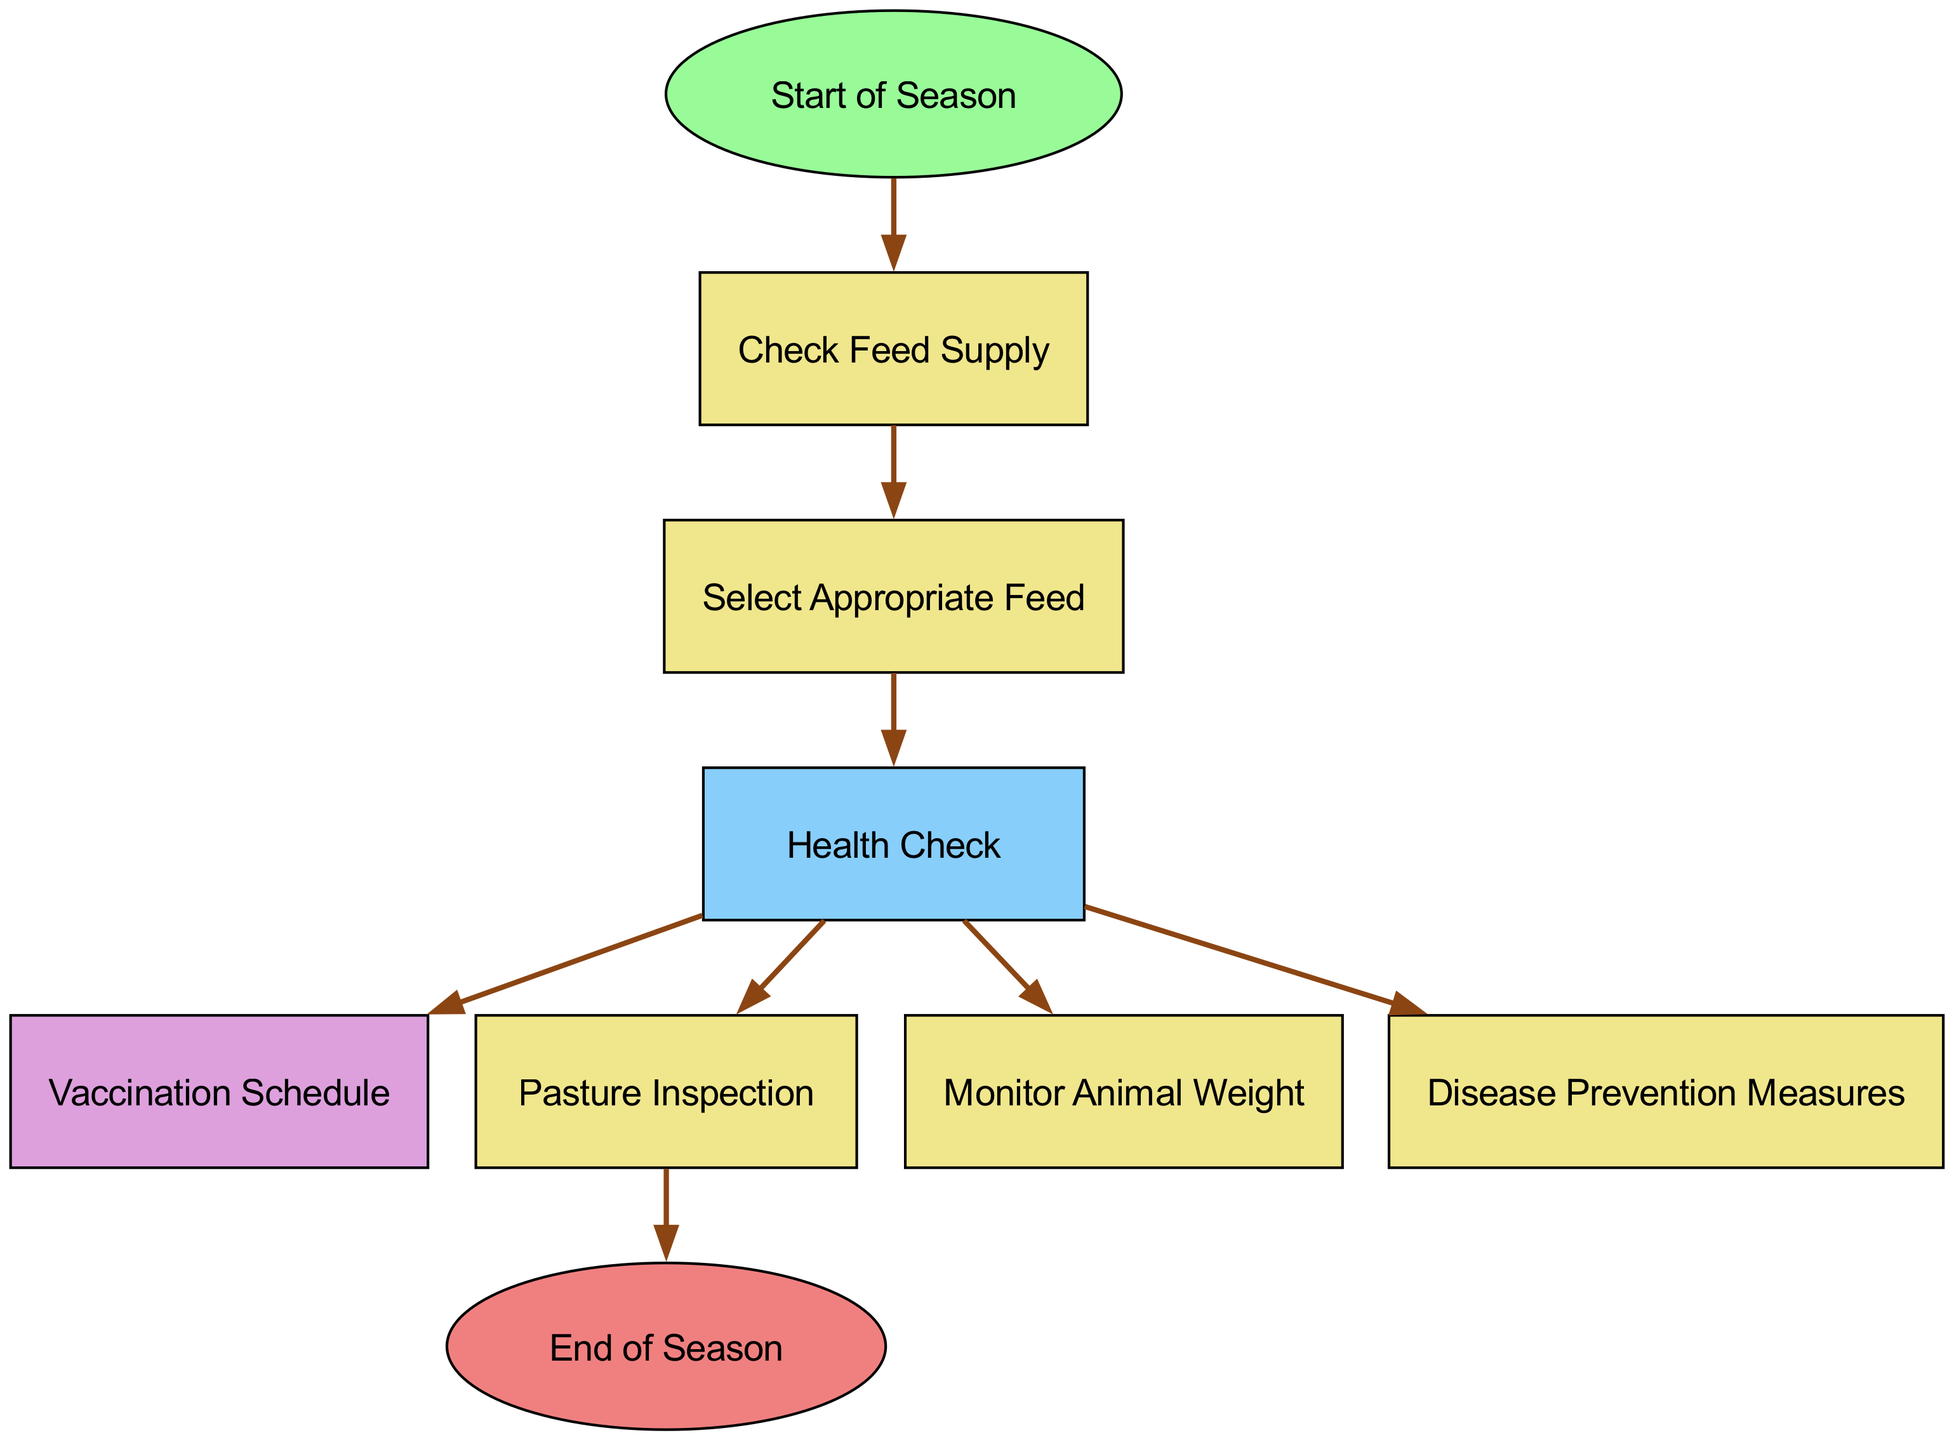What is the first step in the seasonal livestock care routine? According to the directed graph, the first step is the "Start of Season," which leads to other activities in the routine.
Answer: Start of Season How many nodes are in the diagram? By counting the individual elements listed in the data, we find there are ten nodes representing various activities related to livestock care.
Answer: 10 What follows after checking the feed supply? The diagram shows that after "Check Feed Supply," the next step is "Select Appropriate Feed," indicating that this is the immediate next activity.
Answer: Select Appropriate Feed Which node leads to both vaccination schedule and disease prevention measures? The "Health Check" node connects to both "Vaccination Schedule" and "Disease Prevention Measures," indicating that a health check is necessary before these actions.
Answer: Health Check What is the last activity before the end of the season? According to the directed graph, the last activity before reaching the "End of Season" is "Pasture Inspection," which indicates a final check before the end.
Answer: Pasture Inspection What color represents the "Health Check" node? The diagram indicates that the "Health Check" node is colored light blue, differentiating it from other nodes visually.
Answer: Light blue How many relationships are there in total in the diagram? The relationships defined in the data are counted, and there are seven connections showing the flow from one activity to another in the care routine.
Answer: 7 Which two nodes have the most outgoing edges? The "Health Check" node has multiple outgoing edges, leading to "Vaccination Schedule," "Monitor Weight," "Disease Prevention," and "Pasture Inspection." It has the most outgoing edges among all nodes.
Answer: Health Check What is the primary focus of the directed graph? The primary focus of the graph is depicted in the activities and their flow concerning seasonal livestock care, particularly in feed management, vaccination, and health checks.
Answer: Seasonal livestock care 